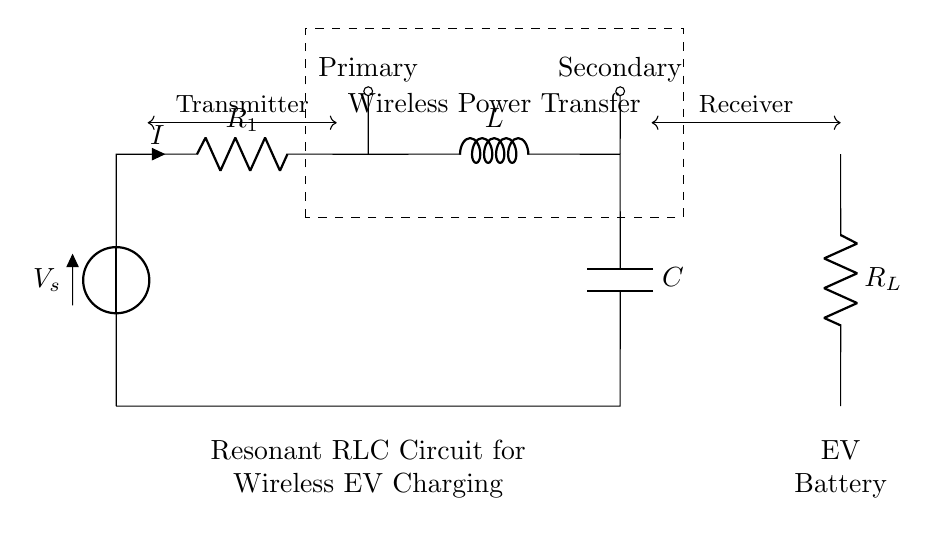What is the power source in this circuit? The power source is indicated by the voltage symbol V_s, located at the left side of the circuit diagram. It provides the necessary voltage for the entire circuit's operation.
Answer: V_s What components are used in the circuit? The components in the circuit are a voltage source, a resistor (R), an inductor (L), and a capacitor (C). Each of these components is labeled in the diagram, identifying their respective roles in the circuit.
Answer: Voltage source, resistor, inductor, capacitor What is the function of the dashed rectangle in the circuit? The dashed rectangle encapsulates the area of the circuit where wireless power transfer occurs, indicating that this section is designated for transferring power wirelessly between the transmitter and receiver.
Answer: Wireless Power Transfer What is the relationship between the primary and secondary sections? The primary section is where power is supplied and managed, while the secondary section receives the transferred power. This establishes a link between the two sections crucial for effective wireless charging in electric vehicle applications.
Answer: Transmitter and Receiver What is the role of the load resistor in this circuit? The load resistor, labeled R_L, represents the load connected to the power transfer system, such as an electric vehicle battery. It absorbs the power delivered from the primary section through the secondary.
Answer: Load What is the expected benefit of using a resonant circuit in wireless charging? A resonant circuit enhances efficiency by allowing the components to operate at a specific frequency, maximizing power transfer between the primary and secondary coils. This results in lower losses and greater effectiveness in charging electric vehicles.
Answer: Efficiency What does the letter 'I' represent in the circuit? The letter 'I' represents the current flowing through the circuit, specifically indicated at the resistorR_1. It denotes the rate of charge flow in the circuit, essential for understanding the power being consumed.
Answer: Current 